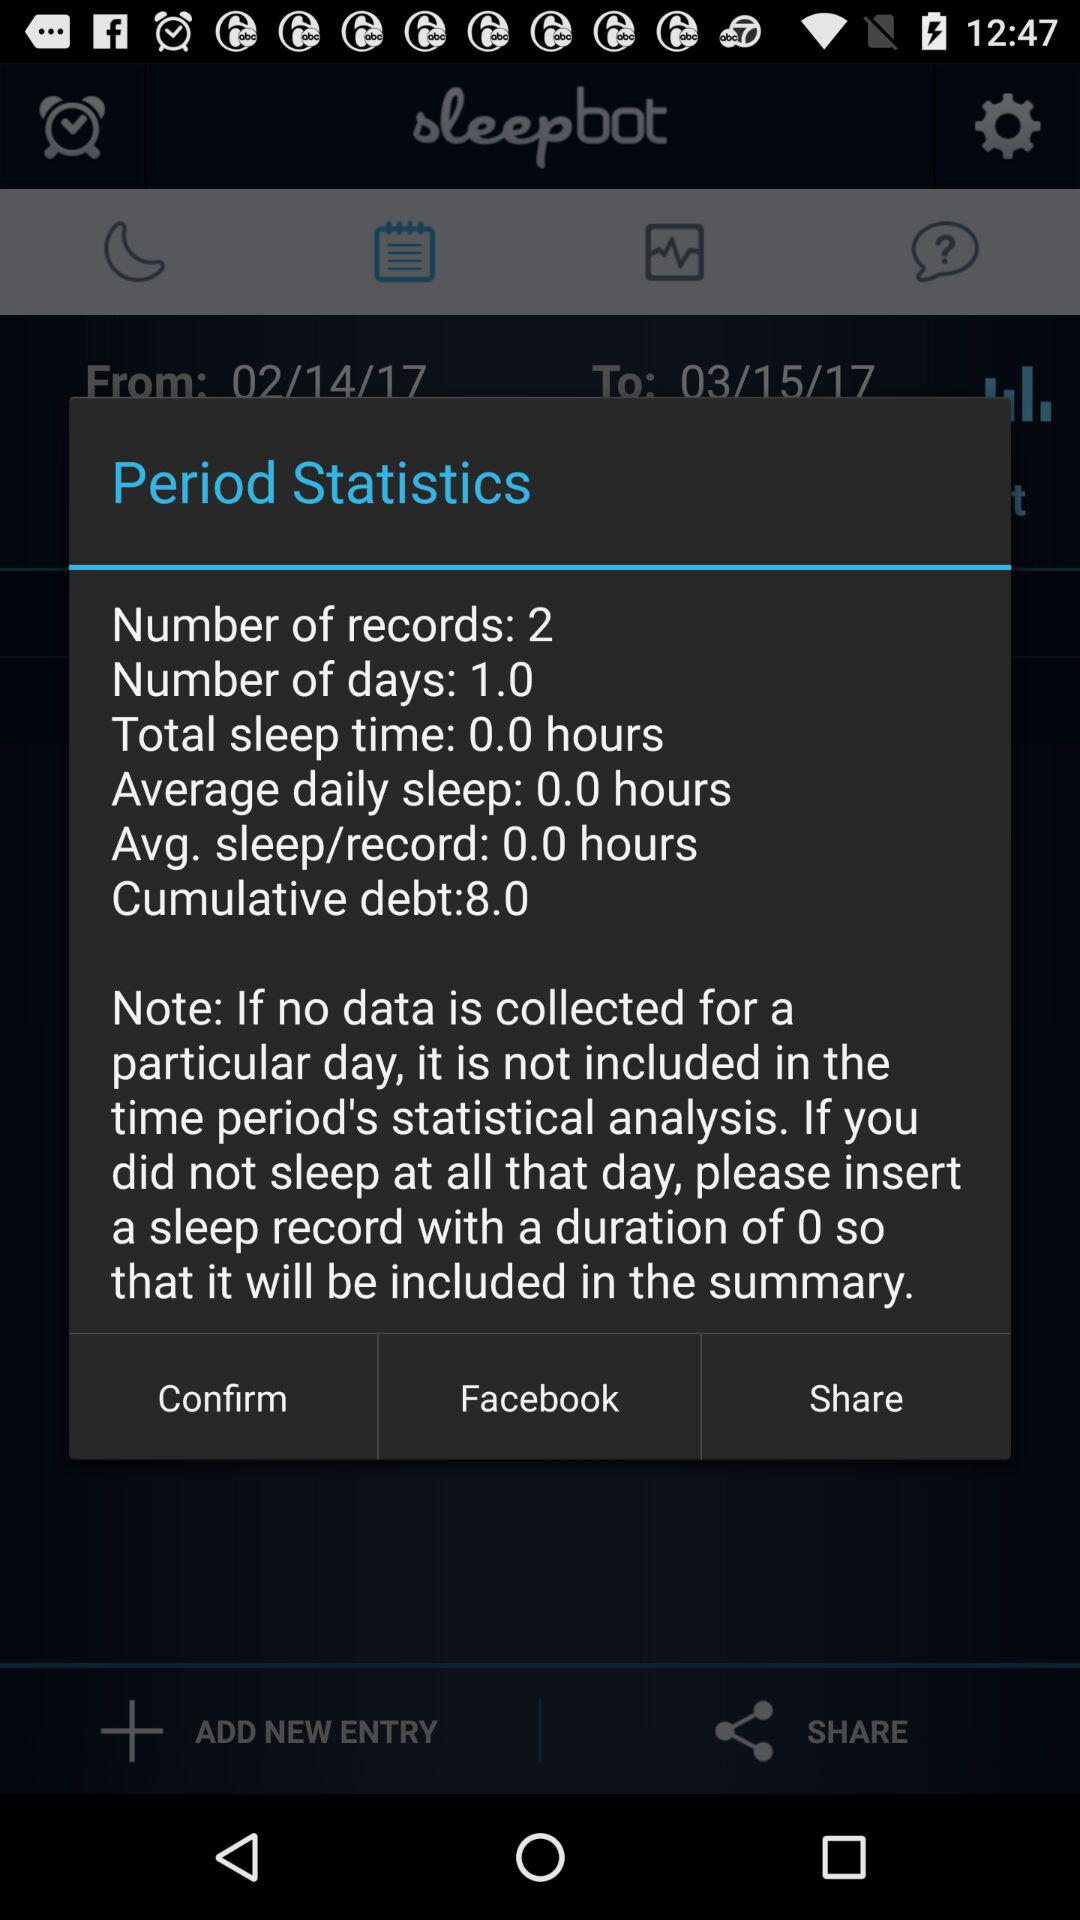What is the total duration of sleep time? The total duration of sleep time is 0.0 hours. 